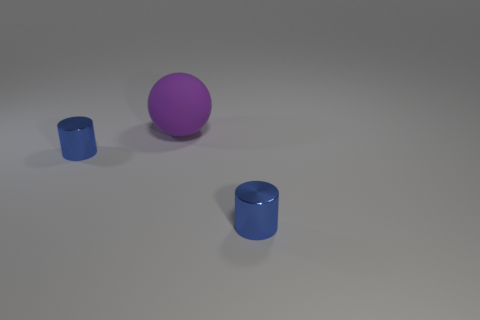Add 1 big red metal balls. How many objects exist? 4 Subtract all cylinders. How many objects are left? 1 Add 2 metallic objects. How many metallic objects are left? 4 Add 3 big spheres. How many big spheres exist? 4 Subtract 0 yellow cylinders. How many objects are left? 3 Subtract all large rubber objects. Subtract all big rubber objects. How many objects are left? 1 